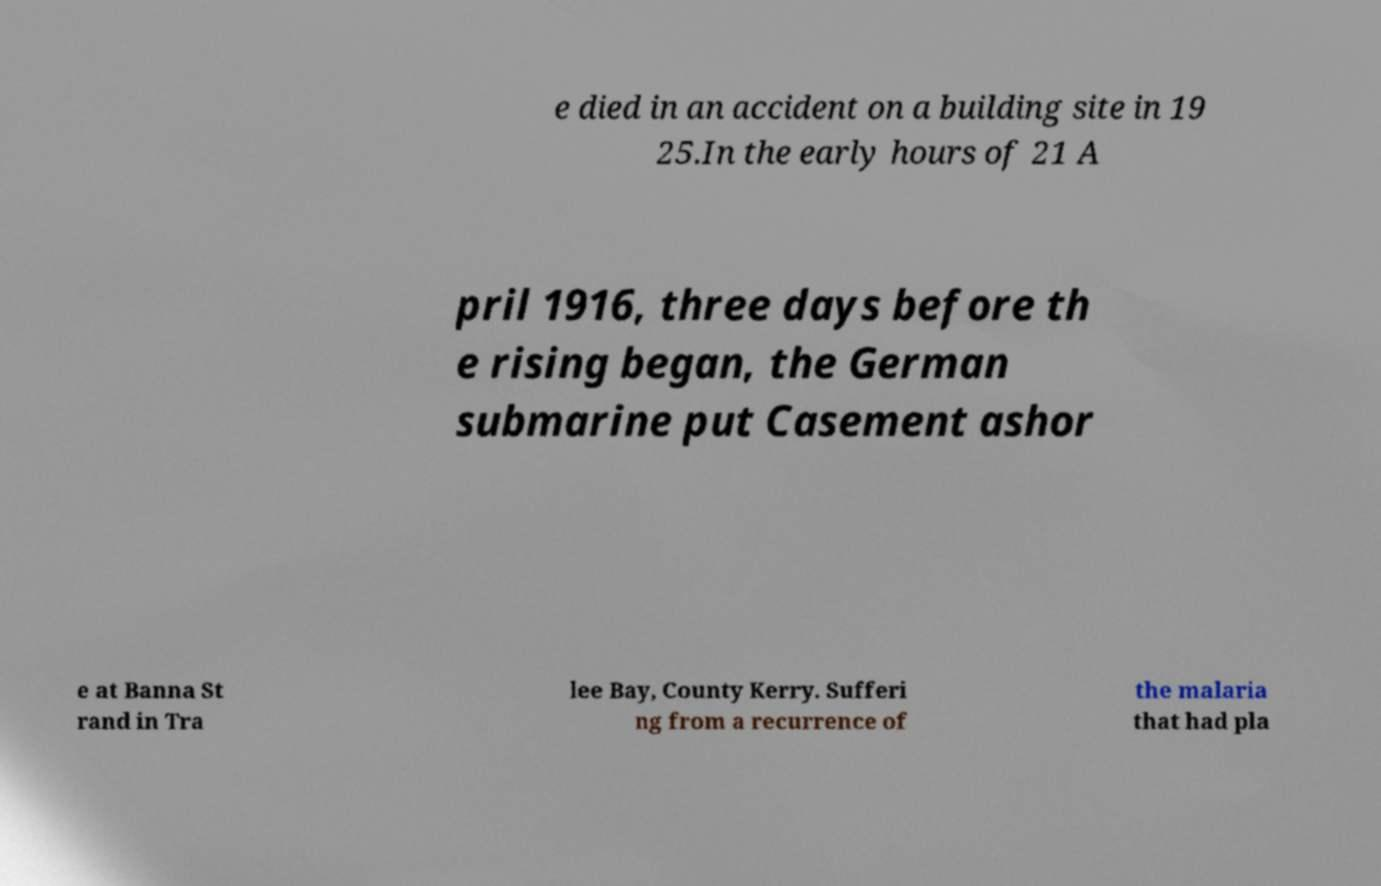I need the written content from this picture converted into text. Can you do that? e died in an accident on a building site in 19 25.In the early hours of 21 A pril 1916, three days before th e rising began, the German submarine put Casement ashor e at Banna St rand in Tra lee Bay, County Kerry. Sufferi ng from a recurrence of the malaria that had pla 